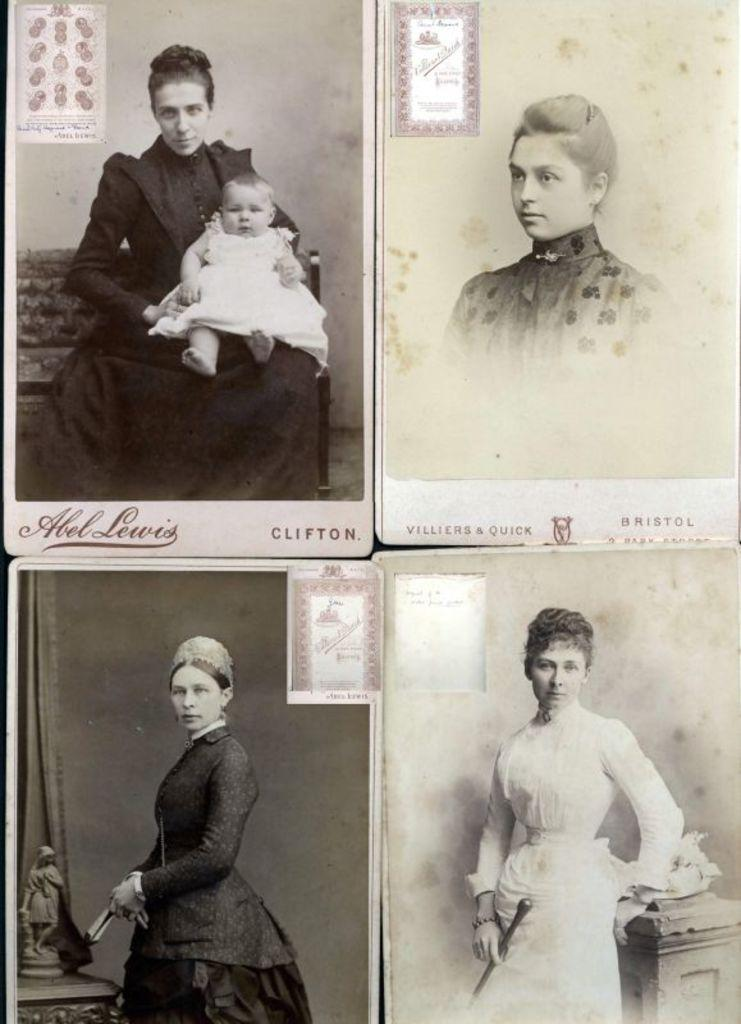What is the color scheme of the image? The image is black and white. What is the main subject of the image? The image is a collage of four different people. Is there any blood visible in the image? No, there is no blood visible in the image, as it is a black and white collage of four different people. What type of bit is being used by the boy in the image? There is no boy present in the image, and therefore no bit can be observed. 